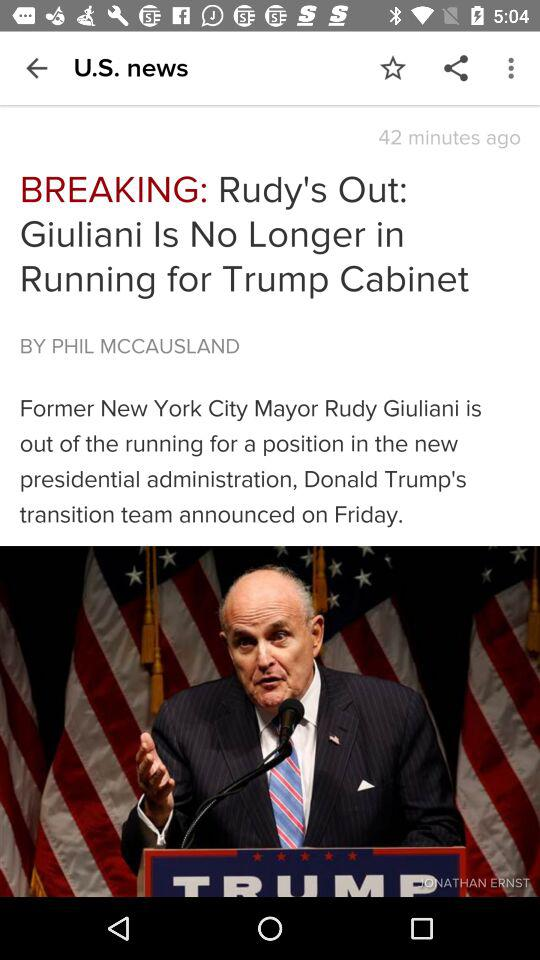How many minutes ago was the article published?
Answer the question using a single word or phrase. 42 